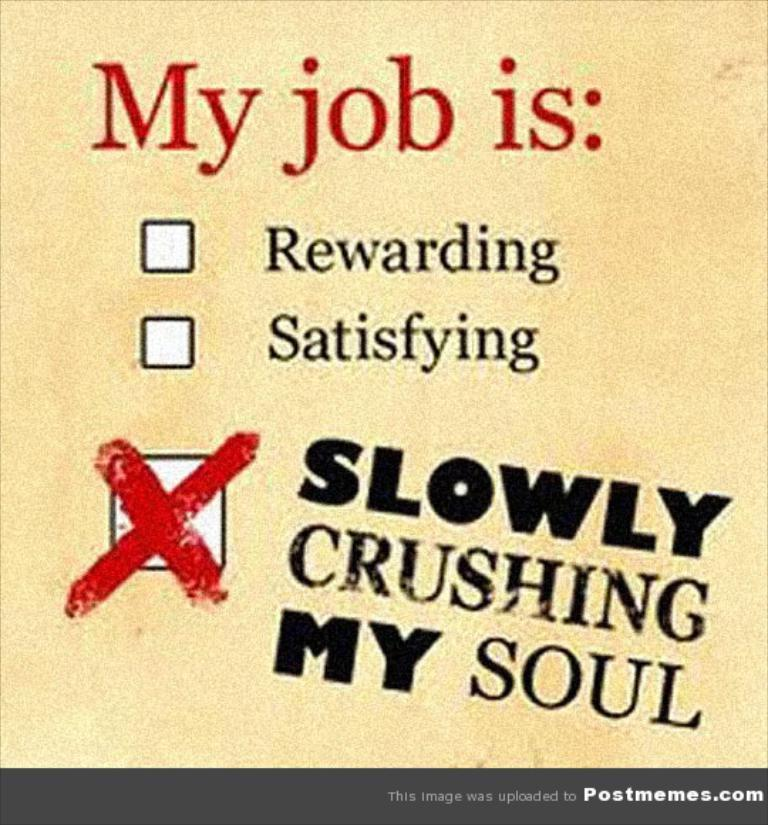<image>
Write a terse but informative summary of the picture. A postmemes.com sign that asks you to answer "My job is." 